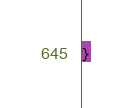Convert code to text. <code><loc_0><loc_0><loc_500><loc_500><_CSS_>}
</code> 